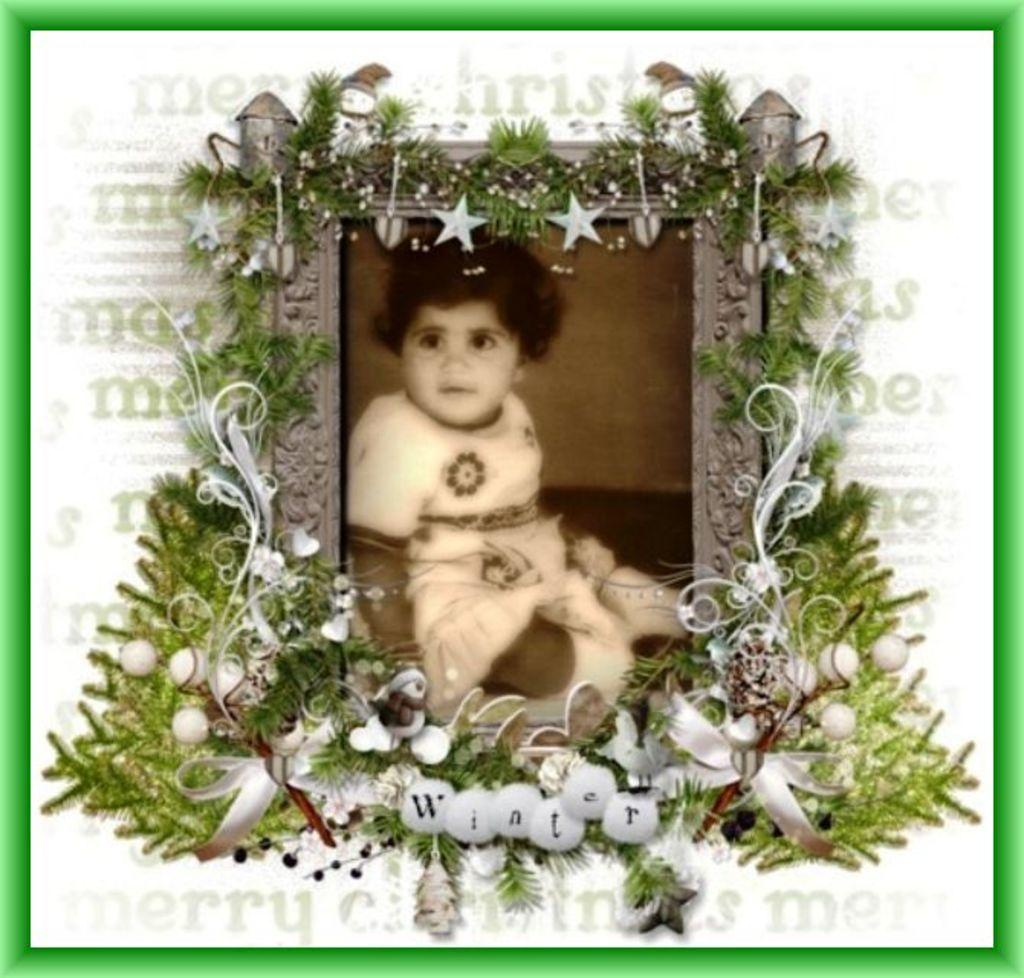What object is present in the image that typically holds a photograph? There is a photo frame in the image. What can be seen inside the photo frame? The photo frame contains a picture of a child. What famous actor is depicted in the photo frame? There is no actor depicted in the photo frame; it contains a picture of a child. Was the photo taken during a battle? There is no indication of a battle in the image; it features a photo frame with a picture of a child. 